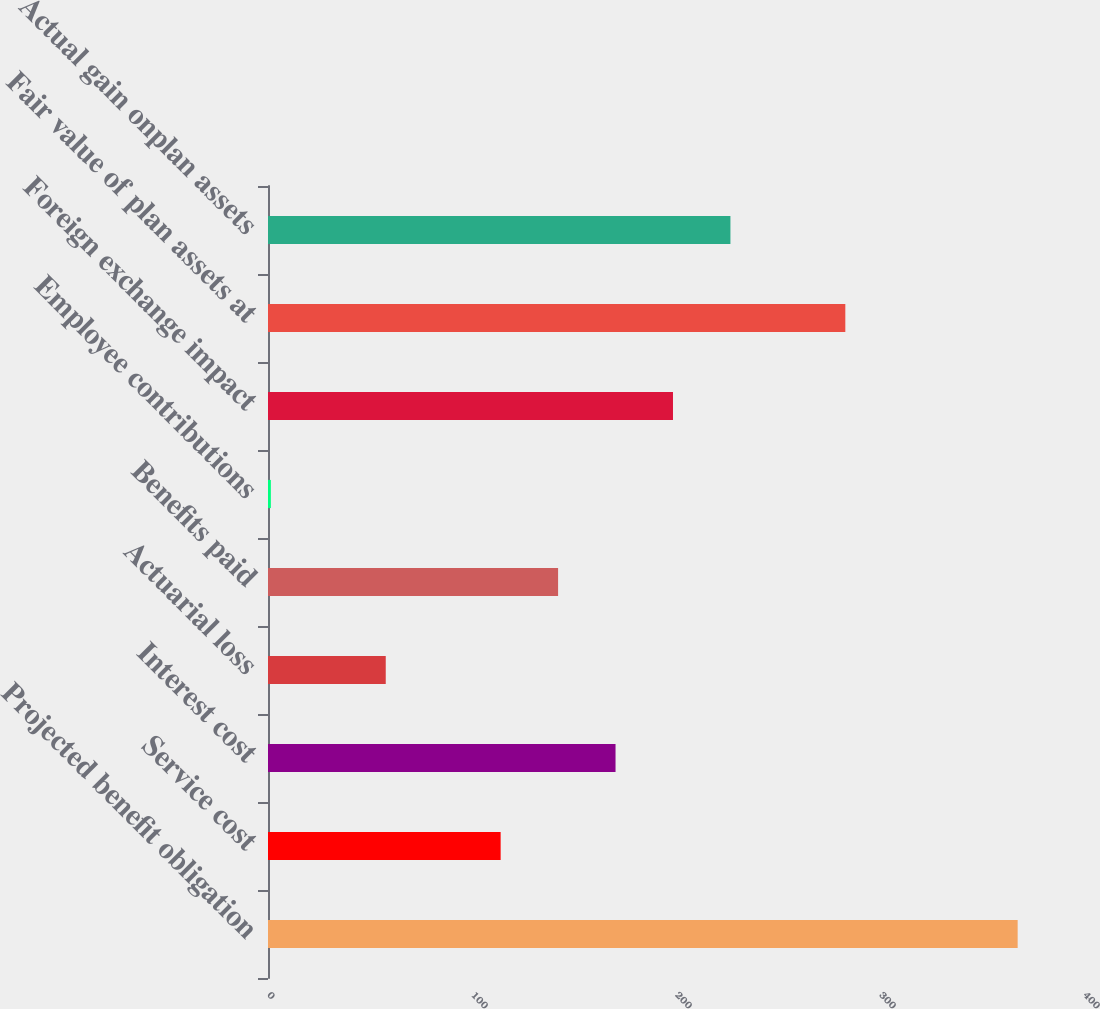Convert chart to OTSL. <chart><loc_0><loc_0><loc_500><loc_500><bar_chart><fcel>Projected benefit obligation<fcel>Service cost<fcel>Interest cost<fcel>Actuarial loss<fcel>Benefits paid<fcel>Employee contributions<fcel>Foreign exchange impact<fcel>Fair value of plan assets at<fcel>Actual gain onplan assets<nl><fcel>367.48<fcel>114.04<fcel>170.36<fcel>57.72<fcel>142.2<fcel>1.4<fcel>198.52<fcel>283<fcel>226.68<nl></chart> 